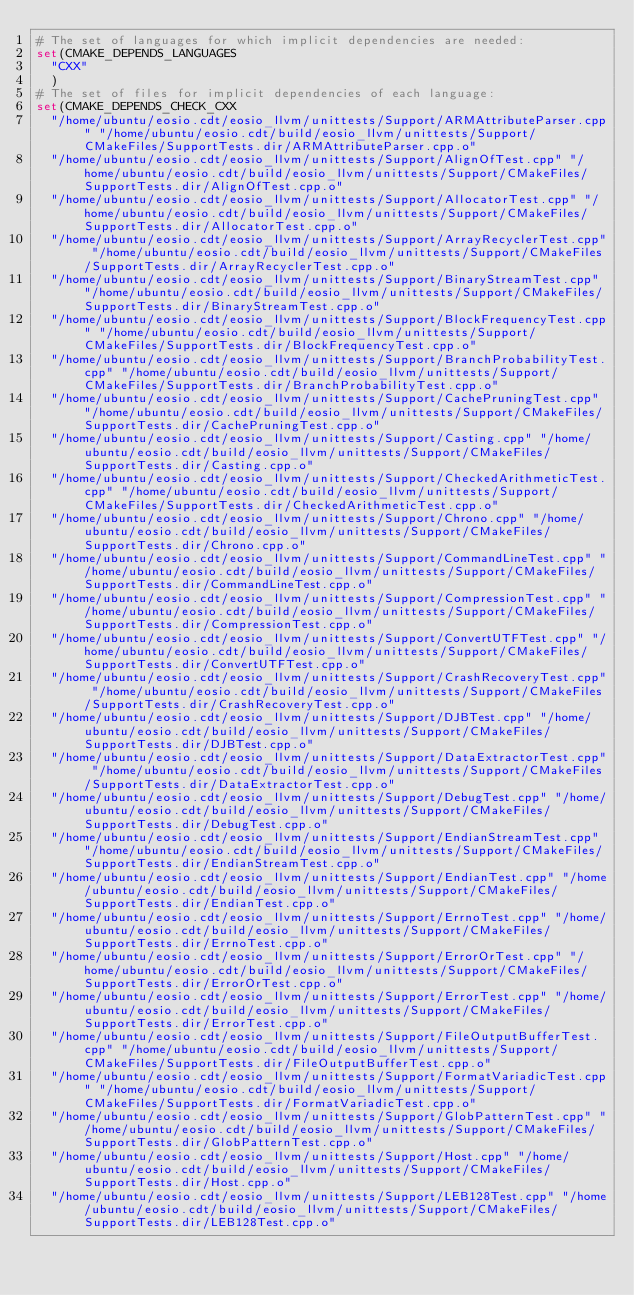Convert code to text. <code><loc_0><loc_0><loc_500><loc_500><_CMake_># The set of languages for which implicit dependencies are needed:
set(CMAKE_DEPENDS_LANGUAGES
  "CXX"
  )
# The set of files for implicit dependencies of each language:
set(CMAKE_DEPENDS_CHECK_CXX
  "/home/ubuntu/eosio.cdt/eosio_llvm/unittests/Support/ARMAttributeParser.cpp" "/home/ubuntu/eosio.cdt/build/eosio_llvm/unittests/Support/CMakeFiles/SupportTests.dir/ARMAttributeParser.cpp.o"
  "/home/ubuntu/eosio.cdt/eosio_llvm/unittests/Support/AlignOfTest.cpp" "/home/ubuntu/eosio.cdt/build/eosio_llvm/unittests/Support/CMakeFiles/SupportTests.dir/AlignOfTest.cpp.o"
  "/home/ubuntu/eosio.cdt/eosio_llvm/unittests/Support/AllocatorTest.cpp" "/home/ubuntu/eosio.cdt/build/eosio_llvm/unittests/Support/CMakeFiles/SupportTests.dir/AllocatorTest.cpp.o"
  "/home/ubuntu/eosio.cdt/eosio_llvm/unittests/Support/ArrayRecyclerTest.cpp" "/home/ubuntu/eosio.cdt/build/eosio_llvm/unittests/Support/CMakeFiles/SupportTests.dir/ArrayRecyclerTest.cpp.o"
  "/home/ubuntu/eosio.cdt/eosio_llvm/unittests/Support/BinaryStreamTest.cpp" "/home/ubuntu/eosio.cdt/build/eosio_llvm/unittests/Support/CMakeFiles/SupportTests.dir/BinaryStreamTest.cpp.o"
  "/home/ubuntu/eosio.cdt/eosio_llvm/unittests/Support/BlockFrequencyTest.cpp" "/home/ubuntu/eosio.cdt/build/eosio_llvm/unittests/Support/CMakeFiles/SupportTests.dir/BlockFrequencyTest.cpp.o"
  "/home/ubuntu/eosio.cdt/eosio_llvm/unittests/Support/BranchProbabilityTest.cpp" "/home/ubuntu/eosio.cdt/build/eosio_llvm/unittests/Support/CMakeFiles/SupportTests.dir/BranchProbabilityTest.cpp.o"
  "/home/ubuntu/eosio.cdt/eosio_llvm/unittests/Support/CachePruningTest.cpp" "/home/ubuntu/eosio.cdt/build/eosio_llvm/unittests/Support/CMakeFiles/SupportTests.dir/CachePruningTest.cpp.o"
  "/home/ubuntu/eosio.cdt/eosio_llvm/unittests/Support/Casting.cpp" "/home/ubuntu/eosio.cdt/build/eosio_llvm/unittests/Support/CMakeFiles/SupportTests.dir/Casting.cpp.o"
  "/home/ubuntu/eosio.cdt/eosio_llvm/unittests/Support/CheckedArithmeticTest.cpp" "/home/ubuntu/eosio.cdt/build/eosio_llvm/unittests/Support/CMakeFiles/SupportTests.dir/CheckedArithmeticTest.cpp.o"
  "/home/ubuntu/eosio.cdt/eosio_llvm/unittests/Support/Chrono.cpp" "/home/ubuntu/eosio.cdt/build/eosio_llvm/unittests/Support/CMakeFiles/SupportTests.dir/Chrono.cpp.o"
  "/home/ubuntu/eosio.cdt/eosio_llvm/unittests/Support/CommandLineTest.cpp" "/home/ubuntu/eosio.cdt/build/eosio_llvm/unittests/Support/CMakeFiles/SupportTests.dir/CommandLineTest.cpp.o"
  "/home/ubuntu/eosio.cdt/eosio_llvm/unittests/Support/CompressionTest.cpp" "/home/ubuntu/eosio.cdt/build/eosio_llvm/unittests/Support/CMakeFiles/SupportTests.dir/CompressionTest.cpp.o"
  "/home/ubuntu/eosio.cdt/eosio_llvm/unittests/Support/ConvertUTFTest.cpp" "/home/ubuntu/eosio.cdt/build/eosio_llvm/unittests/Support/CMakeFiles/SupportTests.dir/ConvertUTFTest.cpp.o"
  "/home/ubuntu/eosio.cdt/eosio_llvm/unittests/Support/CrashRecoveryTest.cpp" "/home/ubuntu/eosio.cdt/build/eosio_llvm/unittests/Support/CMakeFiles/SupportTests.dir/CrashRecoveryTest.cpp.o"
  "/home/ubuntu/eosio.cdt/eosio_llvm/unittests/Support/DJBTest.cpp" "/home/ubuntu/eosio.cdt/build/eosio_llvm/unittests/Support/CMakeFiles/SupportTests.dir/DJBTest.cpp.o"
  "/home/ubuntu/eosio.cdt/eosio_llvm/unittests/Support/DataExtractorTest.cpp" "/home/ubuntu/eosio.cdt/build/eosio_llvm/unittests/Support/CMakeFiles/SupportTests.dir/DataExtractorTest.cpp.o"
  "/home/ubuntu/eosio.cdt/eosio_llvm/unittests/Support/DebugTest.cpp" "/home/ubuntu/eosio.cdt/build/eosio_llvm/unittests/Support/CMakeFiles/SupportTests.dir/DebugTest.cpp.o"
  "/home/ubuntu/eosio.cdt/eosio_llvm/unittests/Support/EndianStreamTest.cpp" "/home/ubuntu/eosio.cdt/build/eosio_llvm/unittests/Support/CMakeFiles/SupportTests.dir/EndianStreamTest.cpp.o"
  "/home/ubuntu/eosio.cdt/eosio_llvm/unittests/Support/EndianTest.cpp" "/home/ubuntu/eosio.cdt/build/eosio_llvm/unittests/Support/CMakeFiles/SupportTests.dir/EndianTest.cpp.o"
  "/home/ubuntu/eosio.cdt/eosio_llvm/unittests/Support/ErrnoTest.cpp" "/home/ubuntu/eosio.cdt/build/eosio_llvm/unittests/Support/CMakeFiles/SupportTests.dir/ErrnoTest.cpp.o"
  "/home/ubuntu/eosio.cdt/eosio_llvm/unittests/Support/ErrorOrTest.cpp" "/home/ubuntu/eosio.cdt/build/eosio_llvm/unittests/Support/CMakeFiles/SupportTests.dir/ErrorOrTest.cpp.o"
  "/home/ubuntu/eosio.cdt/eosio_llvm/unittests/Support/ErrorTest.cpp" "/home/ubuntu/eosio.cdt/build/eosio_llvm/unittests/Support/CMakeFiles/SupportTests.dir/ErrorTest.cpp.o"
  "/home/ubuntu/eosio.cdt/eosio_llvm/unittests/Support/FileOutputBufferTest.cpp" "/home/ubuntu/eosio.cdt/build/eosio_llvm/unittests/Support/CMakeFiles/SupportTests.dir/FileOutputBufferTest.cpp.o"
  "/home/ubuntu/eosio.cdt/eosio_llvm/unittests/Support/FormatVariadicTest.cpp" "/home/ubuntu/eosio.cdt/build/eosio_llvm/unittests/Support/CMakeFiles/SupportTests.dir/FormatVariadicTest.cpp.o"
  "/home/ubuntu/eosio.cdt/eosio_llvm/unittests/Support/GlobPatternTest.cpp" "/home/ubuntu/eosio.cdt/build/eosio_llvm/unittests/Support/CMakeFiles/SupportTests.dir/GlobPatternTest.cpp.o"
  "/home/ubuntu/eosio.cdt/eosio_llvm/unittests/Support/Host.cpp" "/home/ubuntu/eosio.cdt/build/eosio_llvm/unittests/Support/CMakeFiles/SupportTests.dir/Host.cpp.o"
  "/home/ubuntu/eosio.cdt/eosio_llvm/unittests/Support/LEB128Test.cpp" "/home/ubuntu/eosio.cdt/build/eosio_llvm/unittests/Support/CMakeFiles/SupportTests.dir/LEB128Test.cpp.o"</code> 